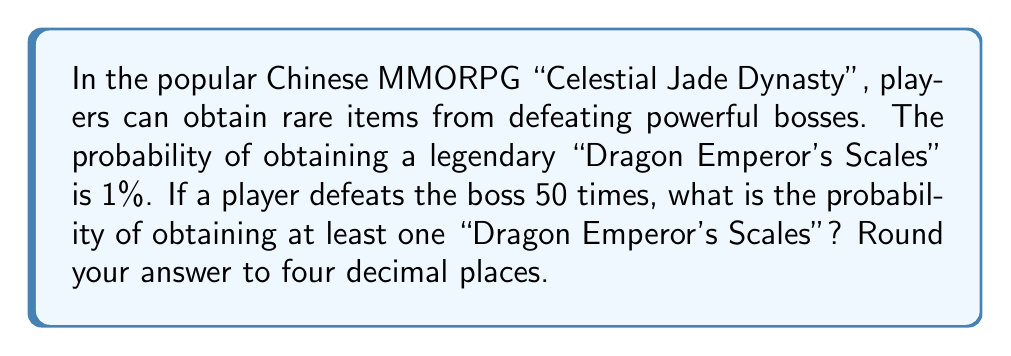Show me your answer to this math problem. To solve this problem, we'll use the complement of the probability of not getting any "Dragon Emperor's Scales" in 50 attempts.

1. Let's define our events:
   $p$ = probability of getting a "Dragon Emperor's Scales" on a single attempt
   $q$ = probability of not getting a "Dragon Emperor's Scales" on a single attempt

2. We know that $p = 0.01$ (1%), so $q = 1 - p = 0.99$ (99%)

3. The probability of not getting any "Dragon Emperor's Scales" in 50 attempts is:
   $P(\text{no scales in 50 attempts}) = q^{50} = 0.99^{50}$

4. Therefore, the probability of getting at least one "Dragon Emperor's Scales" in 50 attempts is:
   $P(\text{at least one scale}) = 1 - P(\text{no scales in 50 attempts})$
   $= 1 - 0.99^{50}$

5. Calculate:
   $1 - 0.99^{50} = 1 - 0.6050$
   $= 0.3950$

6. Round to four decimal places:
   $0.3950$ rounds to $0.3950$
Answer: $0.3950$ or $39.50\%$ 